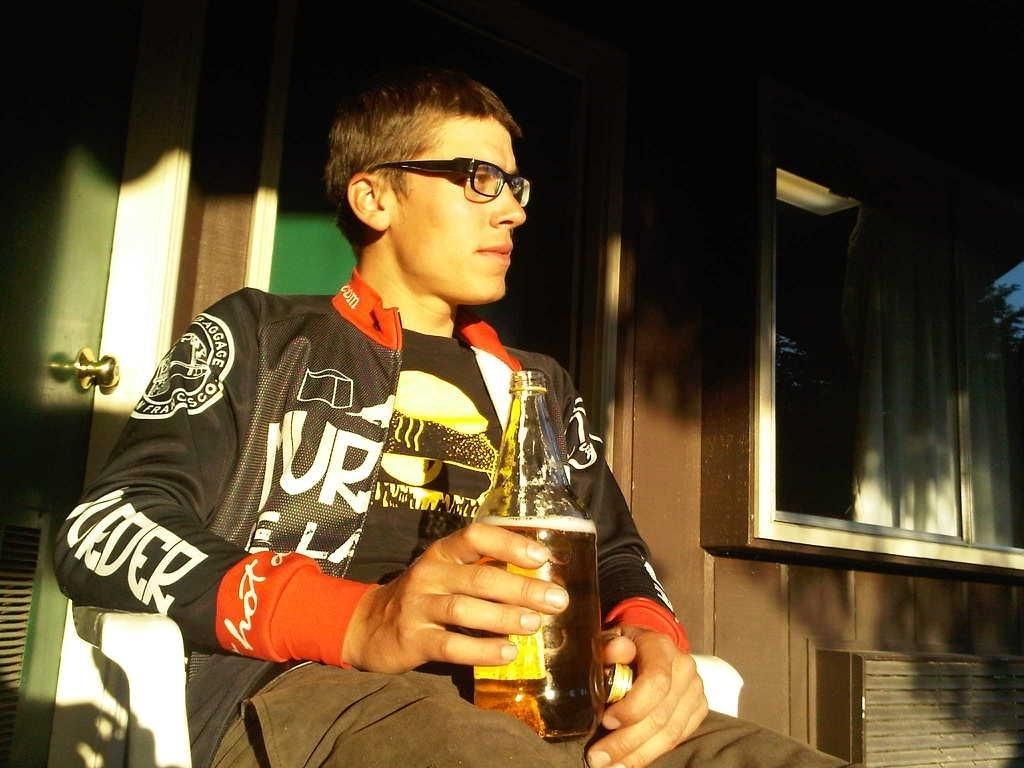What is the person in the image doing? The person is sitting on a chair. What is the person holding in the image? The person is holding a bottle. Can you describe any accessories the person is wearing? The person is wearing glasses. What can be seen in the background of the image? There is a wall, a door, a board, and a glass window in the background. What news is the boy sharing with his pet in the image? There is no boy or pet present in the image. 